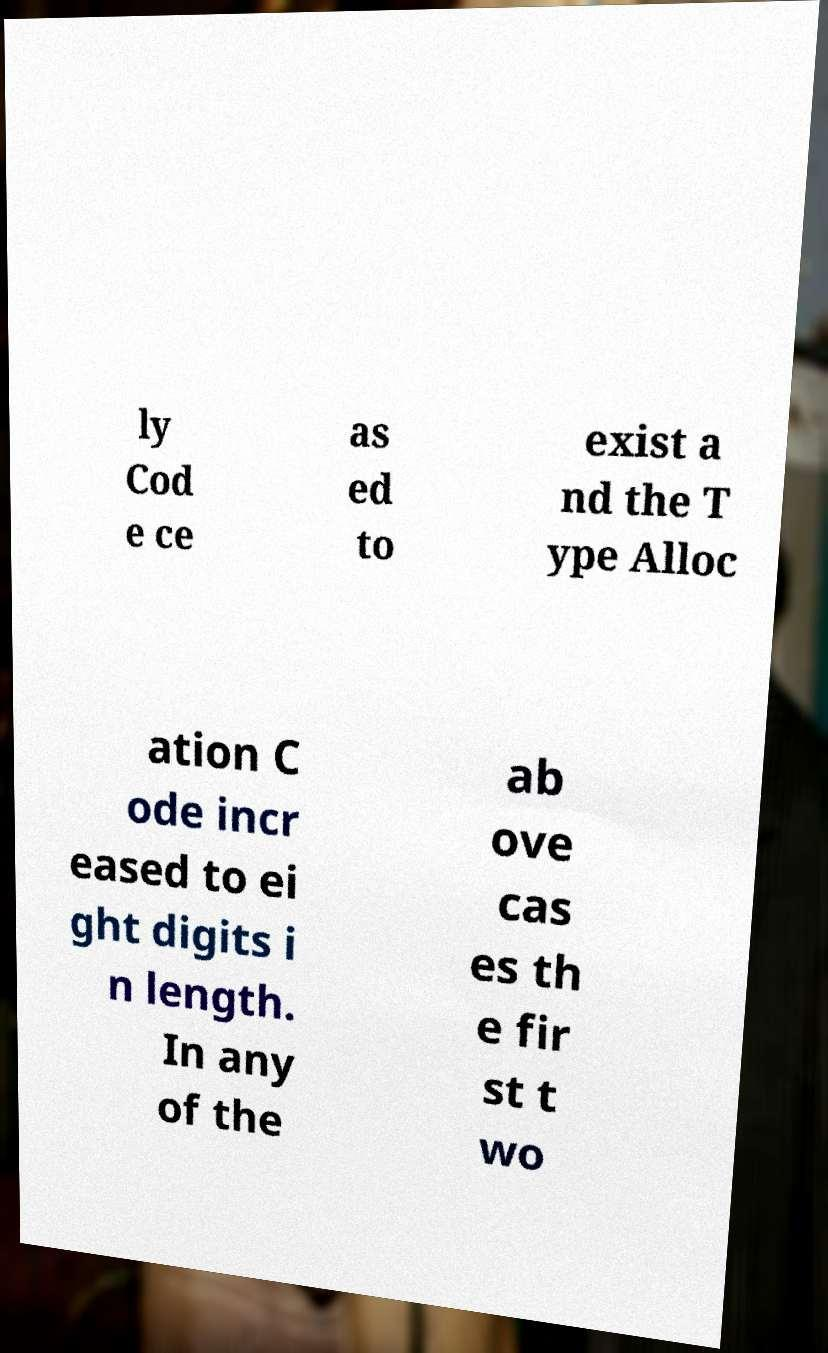Can you read and provide the text displayed in the image?This photo seems to have some interesting text. Can you extract and type it out for me? ly Cod e ce as ed to exist a nd the T ype Alloc ation C ode incr eased to ei ght digits i n length. In any of the ab ove cas es th e fir st t wo 